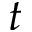Convert formula to latex. <formula><loc_0><loc_0><loc_500><loc_500>t</formula> 